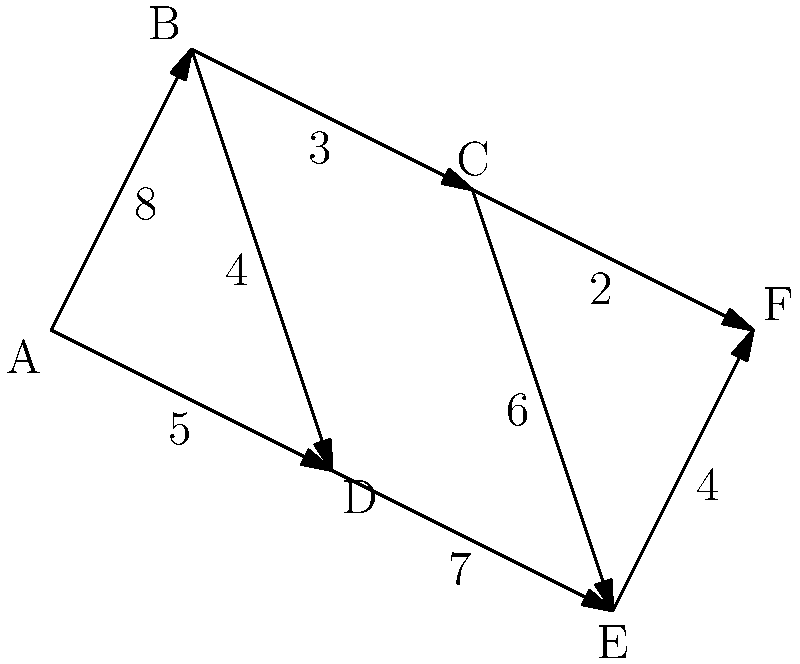A travel agency specializes in off-the-beaten-path destinations. The network diagram above represents lesser-known cities and the travel times (in hours) between them. What is the shortest total travel time from city A to city F, and which route should be taken? To find the shortest path from A to F, we'll use Dijkstra's algorithm:

1. Initialize:
   - Distance to A: 0
   - Distance to all other nodes: infinity
   - Previous node for all: undefined

2. Visit A:
   - Update B: 8 hours
   - Update D: 5 hours

3. Visit D (closest unvisited):
   - Update E: 5 + 7 = 12 hours

4. Visit B:
   - Update C: 8 + 3 = 11 hours

5. Visit C:
   - Update F: 11 + 2 = 13 hours
   - Update E: 11 + 6 = 17 hours (not shorter than current)

6. Visit F:
   - All nodes visited, algorithm complete

The shortest path is A → B → C → F, with a total travel time of 13 hours.

Step-by-step route:
1. A to B: 8 hours
2. B to C: 3 hours
3. C to F: 2 hours

Total: 8 + 3 + 2 = 13 hours
Answer: 13 hours; route A → B → C → F 